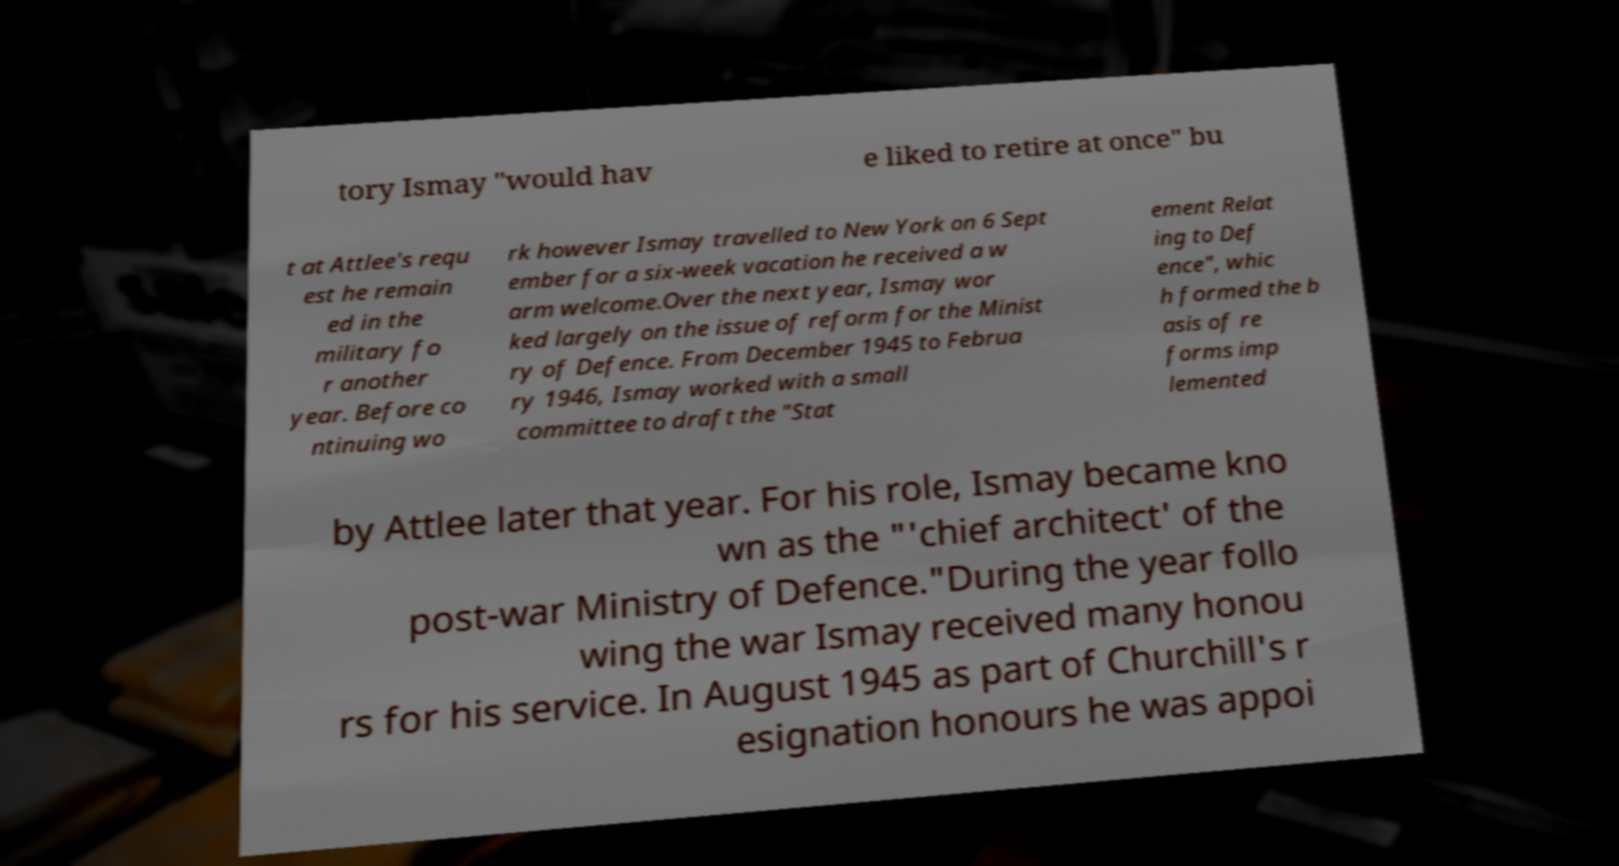Could you extract and type out the text from this image? tory Ismay "would hav e liked to retire at once" bu t at Attlee's requ est he remain ed in the military fo r another year. Before co ntinuing wo rk however Ismay travelled to New York on 6 Sept ember for a six-week vacation he received a w arm welcome.Over the next year, Ismay wor ked largely on the issue of reform for the Minist ry of Defence. From December 1945 to Februa ry 1946, Ismay worked with a small committee to draft the "Stat ement Relat ing to Def ence", whic h formed the b asis of re forms imp lemented by Attlee later that year. For his role, Ismay became kno wn as the "'chief architect' of the post-war Ministry of Defence."During the year follo wing the war Ismay received many honou rs for his service. In August 1945 as part of Churchill's r esignation honours he was appoi 